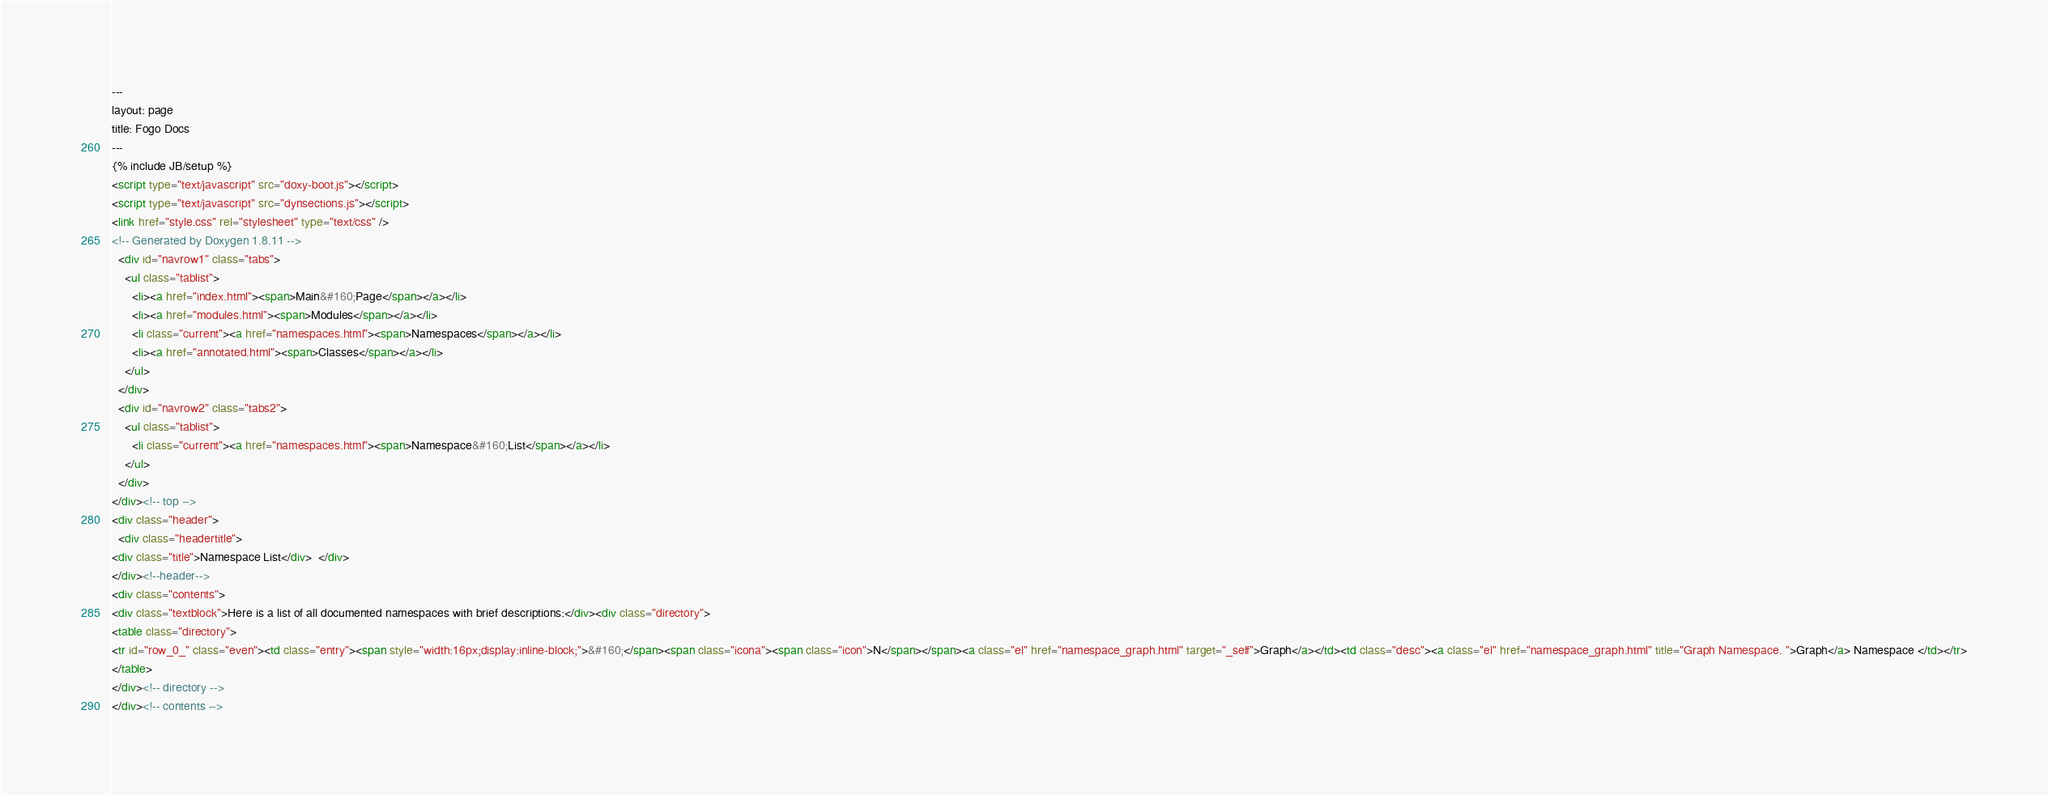Convert code to text. <code><loc_0><loc_0><loc_500><loc_500><_HTML_>---
layout: page
title: Fogo Docs
---
{% include JB/setup %}
<script type="text/javascript" src="doxy-boot.js"></script>
<script type="text/javascript" src="dynsections.js"></script>
<link href="style.css" rel="stylesheet" type="text/css" />
<!-- Generated by Doxygen 1.8.11 -->
  <div id="navrow1" class="tabs">
    <ul class="tablist">
      <li><a href="index.html"><span>Main&#160;Page</span></a></li>
      <li><a href="modules.html"><span>Modules</span></a></li>
      <li class="current"><a href="namespaces.html"><span>Namespaces</span></a></li>
      <li><a href="annotated.html"><span>Classes</span></a></li>
    </ul>
  </div>
  <div id="navrow2" class="tabs2">
    <ul class="tablist">
      <li class="current"><a href="namespaces.html"><span>Namespace&#160;List</span></a></li>
    </ul>
  </div>
</div><!-- top -->
<div class="header">
  <div class="headertitle">
<div class="title">Namespace List</div>  </div>
</div><!--header-->
<div class="contents">
<div class="textblock">Here is a list of all documented namespaces with brief descriptions:</div><div class="directory">
<table class="directory">
<tr id="row_0_" class="even"><td class="entry"><span style="width:16px;display:inline-block;">&#160;</span><span class="icona"><span class="icon">N</span></span><a class="el" href="namespace_graph.html" target="_self">Graph</a></td><td class="desc"><a class="el" href="namespace_graph.html" title="Graph Namespace. ">Graph</a> Namespace </td></tr>
</table>
</div><!-- directory -->
</div><!-- contents -->
</code> 